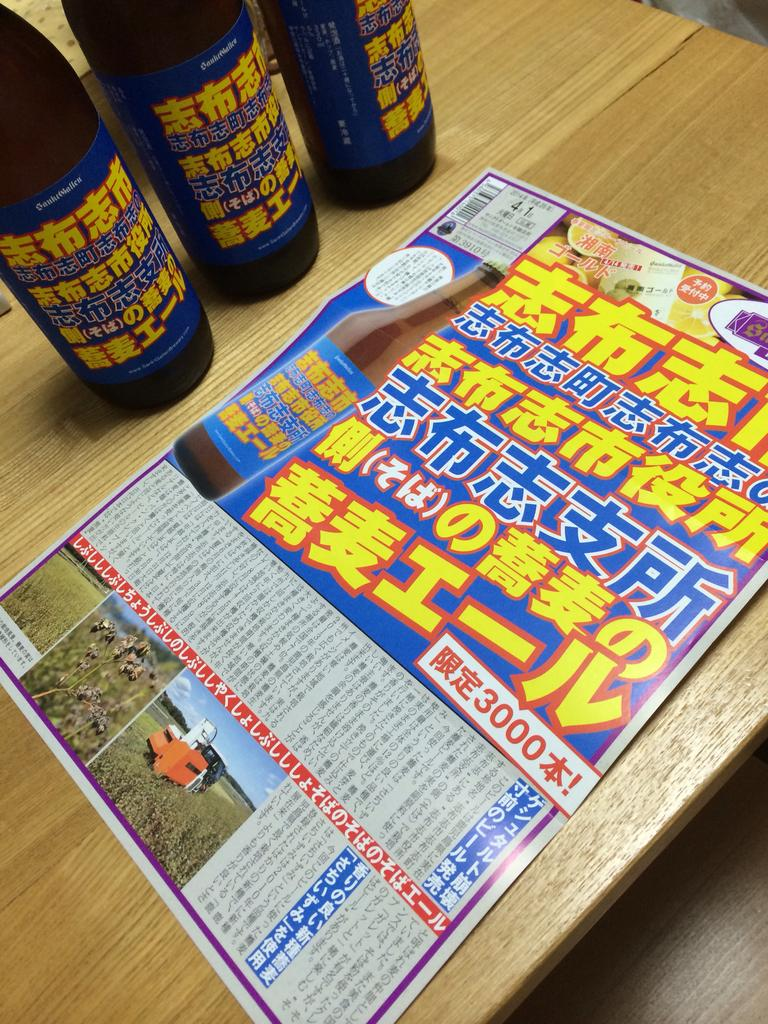<image>
Render a clear and concise summary of the photo. Japeneese drinks and a paper that reads 3000 sits on a table. 